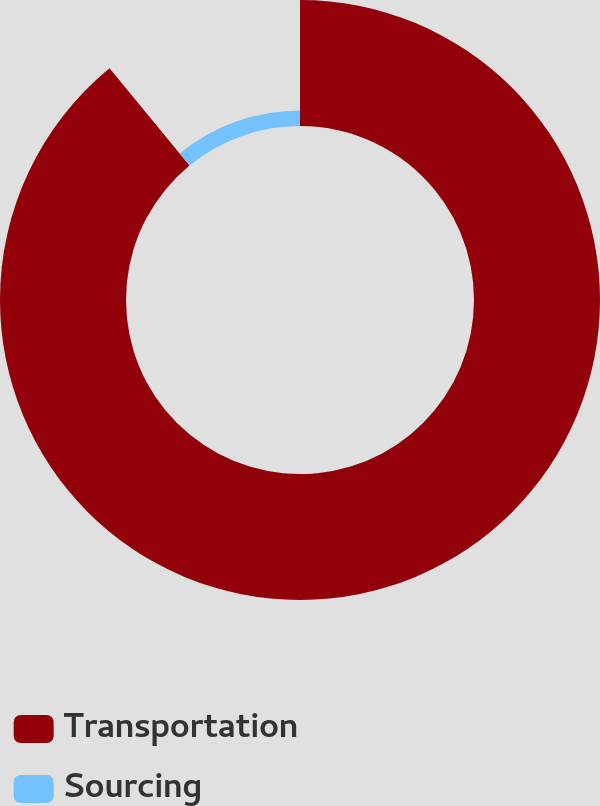Convert chart. <chart><loc_0><loc_0><loc_500><loc_500><pie_chart><fcel>Transportation<fcel>Sourcing<nl><fcel>89.05%<fcel>10.95%<nl></chart> 